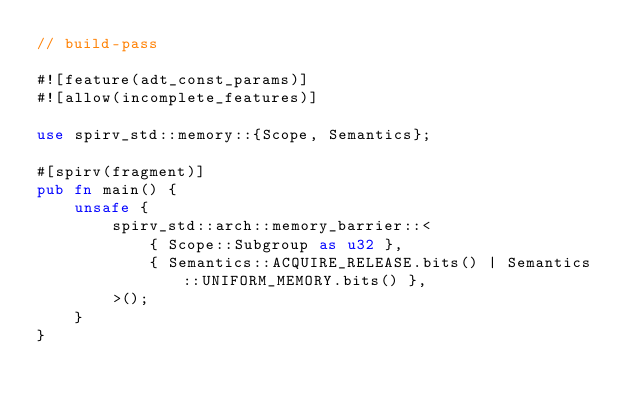<code> <loc_0><loc_0><loc_500><loc_500><_Rust_>// build-pass

#![feature(adt_const_params)]
#![allow(incomplete_features)]

use spirv_std::memory::{Scope, Semantics};

#[spirv(fragment)]
pub fn main() {
    unsafe {
        spirv_std::arch::memory_barrier::<
            { Scope::Subgroup as u32 },
            { Semantics::ACQUIRE_RELEASE.bits() | Semantics::UNIFORM_MEMORY.bits() },
        >();
    }
}
</code> 